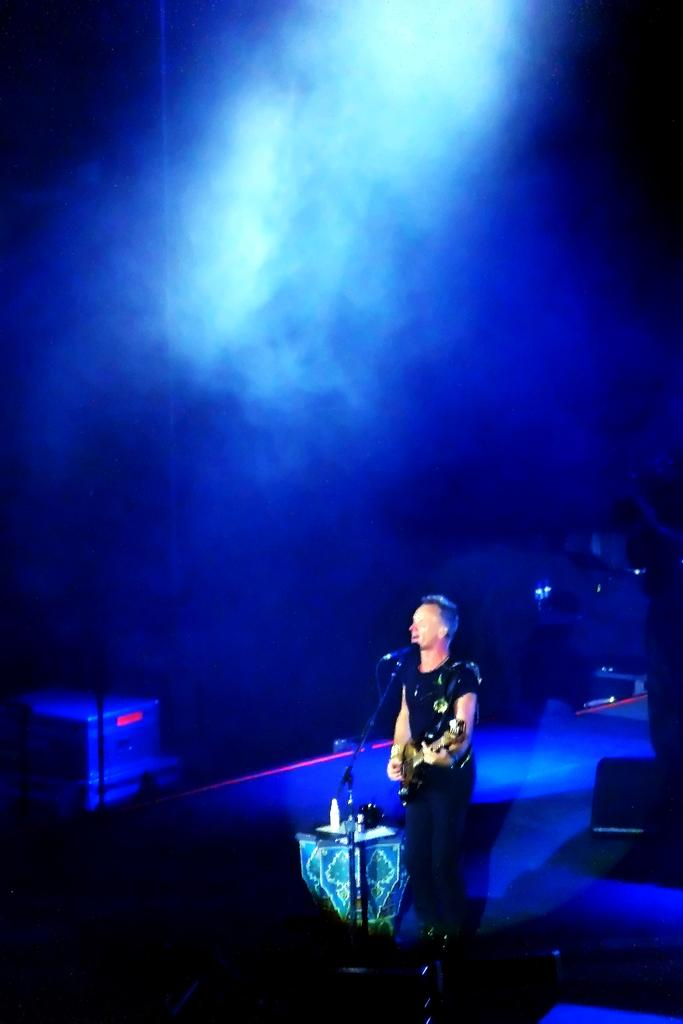What is the man in the image doing? The man is singing on a microphone and holding a guitar. What instrument is the man holding? The man is holding a guitar. Can you describe the background of the image? There are objects visible in the background of the image. What type of government is depicted in the image? There is no depiction of a government in the image; it features a man singing on a microphone and holding a guitar. What class of students is present in the image? There are no students present in the image. 